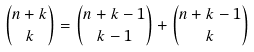<formula> <loc_0><loc_0><loc_500><loc_500>\binom { n + k } k = \binom { n + k - 1 } { k - 1 } + \binom { n + k - 1 } k</formula> 